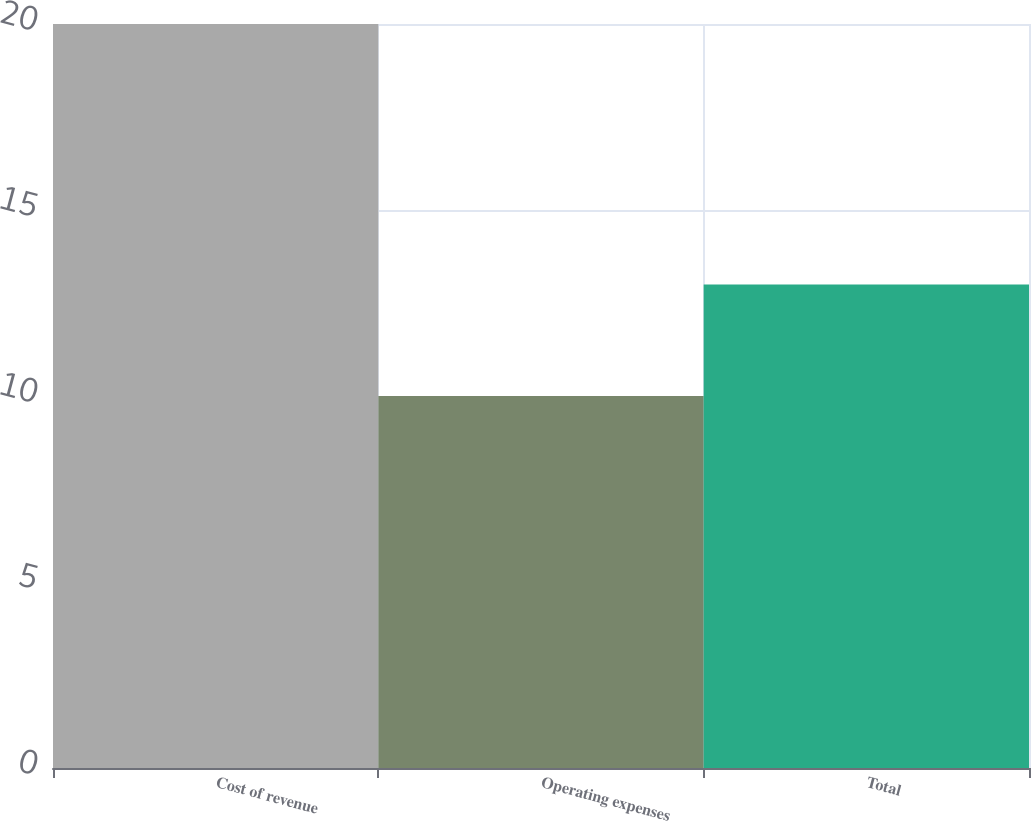Convert chart to OTSL. <chart><loc_0><loc_0><loc_500><loc_500><bar_chart><fcel>Cost of revenue<fcel>Operating expenses<fcel>Total<nl><fcel>20<fcel>10<fcel>13<nl></chart> 